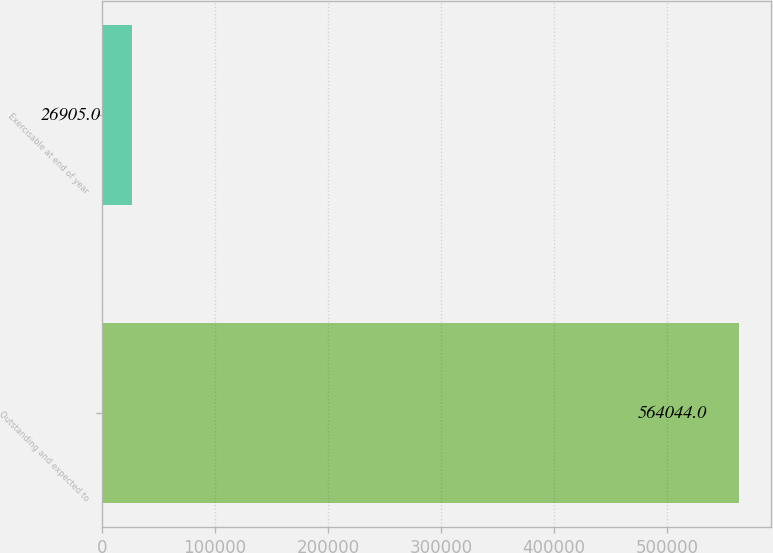Convert chart to OTSL. <chart><loc_0><loc_0><loc_500><loc_500><bar_chart><fcel>Outstanding and expected to<fcel>Exercisable at end of year<nl><fcel>564044<fcel>26905<nl></chart> 